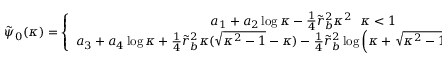Convert formula to latex. <formula><loc_0><loc_0><loc_500><loc_500>\begin{array} { r } { \tilde { \psi } _ { 0 } ( \kappa ) = \left \{ \begin{array} { c } { a _ { 1 } + a _ { 2 } \log \kappa - \frac { 1 } { 4 } \tilde { r } _ { b } ^ { 2 } \kappa ^ { 2 } \kappa < 1 } \\ { a _ { 3 } + a _ { 4 } \log \kappa + \frac { 1 } { 4 } \tilde { r } _ { b } ^ { 2 } \kappa ( \sqrt { \kappa ^ { 2 } - 1 } - \kappa ) - \frac { 1 } { 4 } \tilde { r } _ { b } ^ { 2 } \log \left ( \kappa + \sqrt { \kappa ^ { 2 } - 1 } \right ) 1 < \kappa \ll \infty } \end{array} , } \end{array}</formula> 